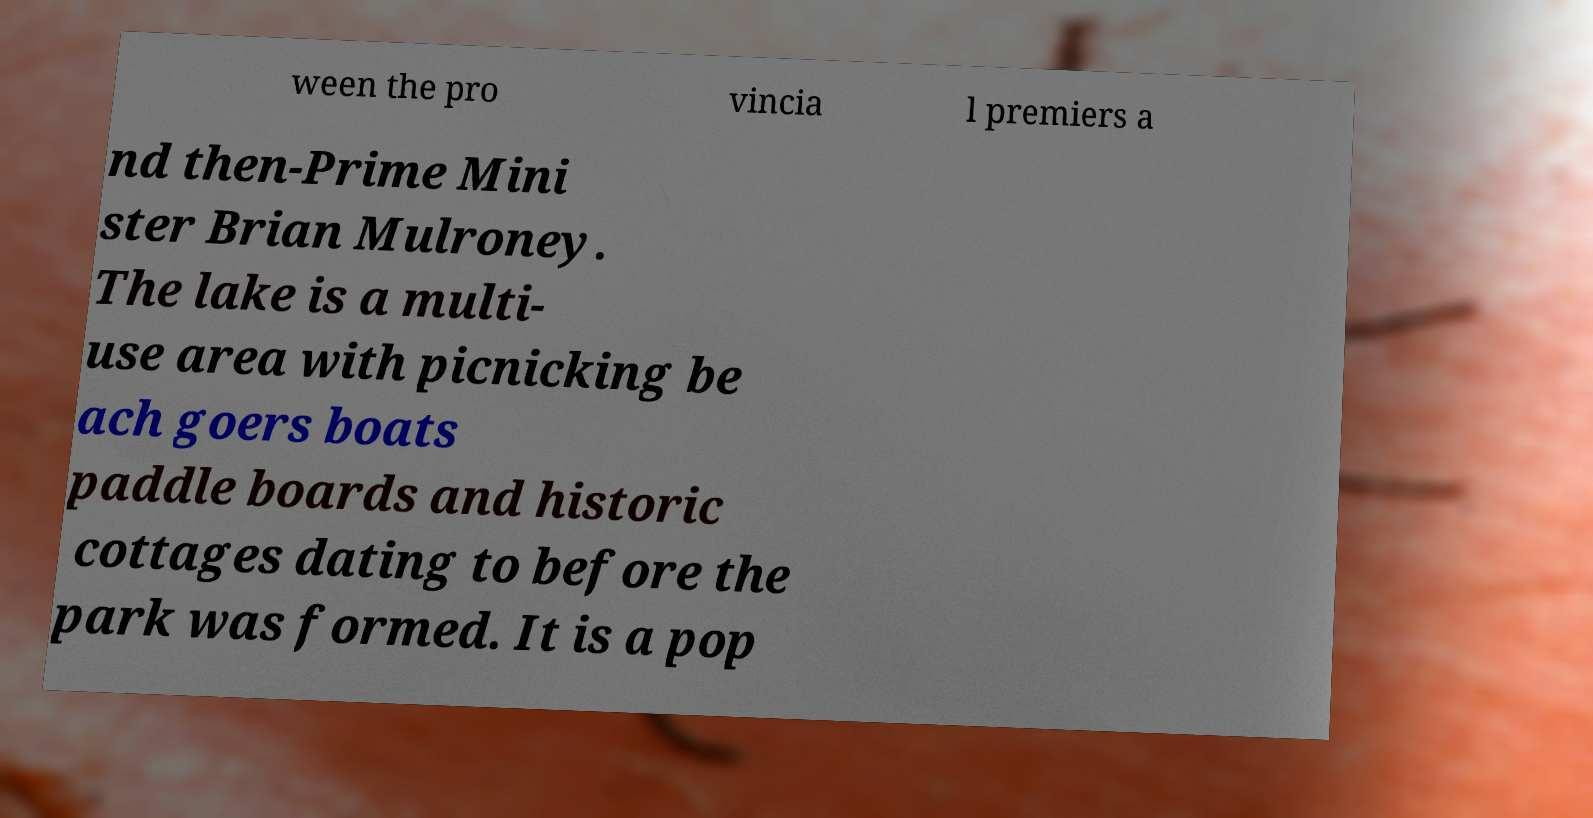What messages or text are displayed in this image? I need them in a readable, typed format. ween the pro vincia l premiers a nd then-Prime Mini ster Brian Mulroney. The lake is a multi- use area with picnicking be ach goers boats paddle boards and historic cottages dating to before the park was formed. It is a pop 